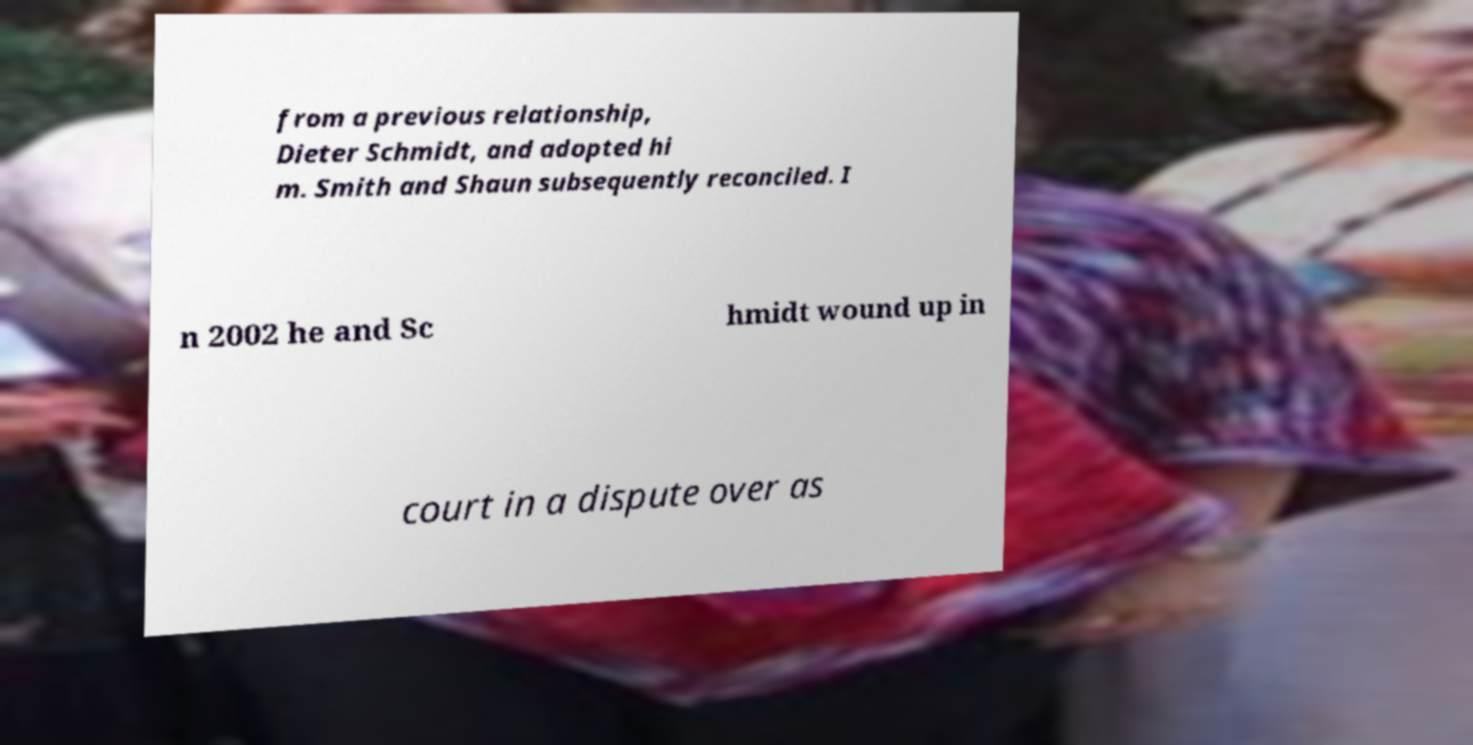I need the written content from this picture converted into text. Can you do that? from a previous relationship, Dieter Schmidt, and adopted hi m. Smith and Shaun subsequently reconciled. I n 2002 he and Sc hmidt wound up in court in a dispute over as 